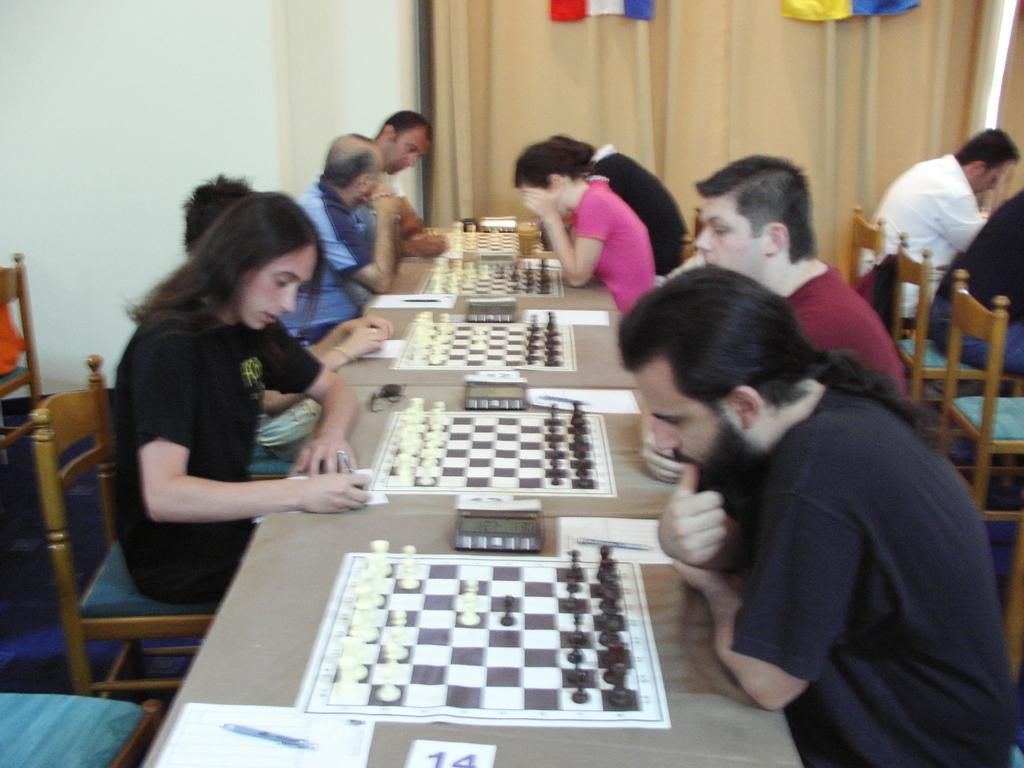What are the people in the image doing? The people are playing chess. What is the main object between the two people? There is a chessboard present. How many people are involved in the game? There are two people involved in the game. What is the secretary's name in the image? There is no secretary present in the image. In which direction are the chess pieces facing? The direction the chess pieces are facing cannot be determined from the image alone, as it depends on the current state of the game. 